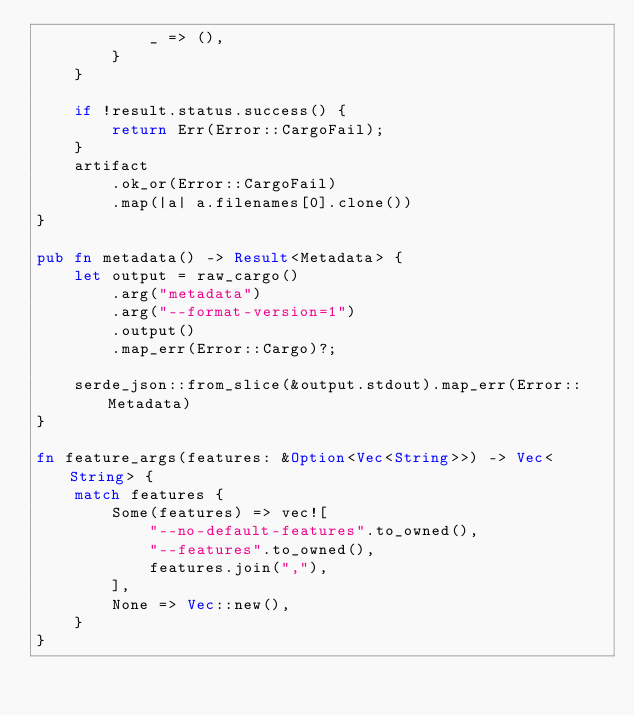<code> <loc_0><loc_0><loc_500><loc_500><_Rust_>            _ => (),
        }
    }

    if !result.status.success() {
        return Err(Error::CargoFail);
    }
    artifact
        .ok_or(Error::CargoFail)
        .map(|a| a.filenames[0].clone())
}

pub fn metadata() -> Result<Metadata> {
    let output = raw_cargo()
        .arg("metadata")
        .arg("--format-version=1")
        .output()
        .map_err(Error::Cargo)?;

    serde_json::from_slice(&output.stdout).map_err(Error::Metadata)
}

fn feature_args(features: &Option<Vec<String>>) -> Vec<String> {
    match features {
        Some(features) => vec![
            "--no-default-features".to_owned(),
            "--features".to_owned(),
            features.join(","),
        ],
        None => Vec::new(),
    }
}
</code> 